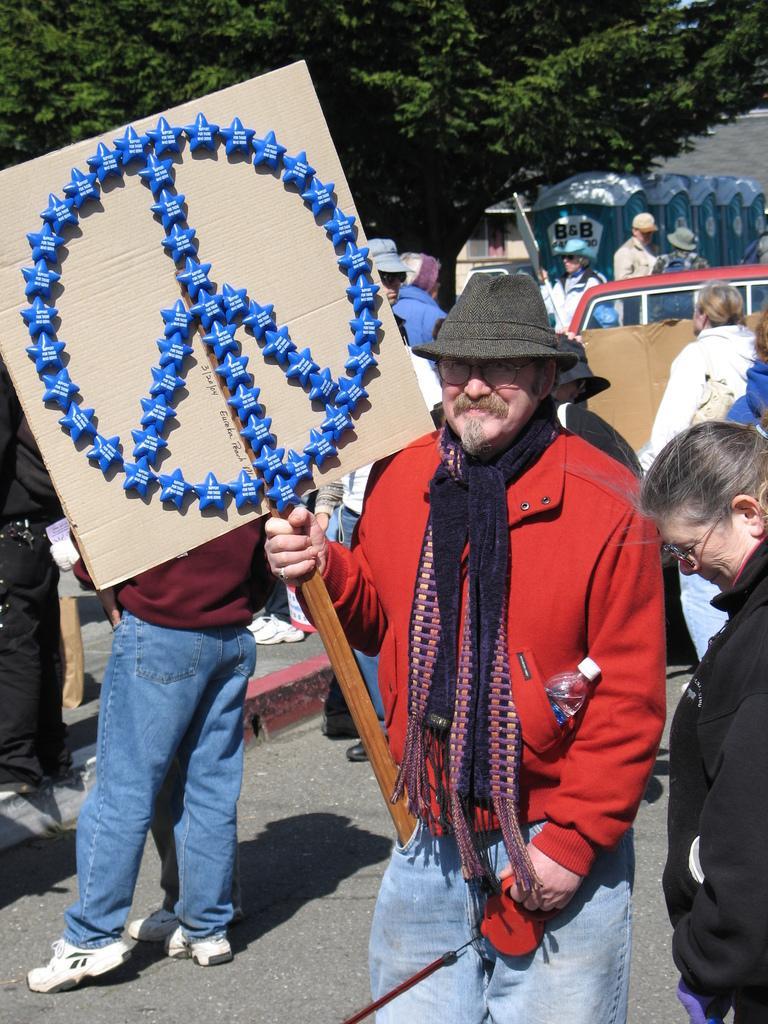Describe this image in one or two sentences. In this picture we can see a man in the red jacket and with a hat. He is holding a placard and an object. Behind the man there are groups of people, a vehicle, trees and some objects. 